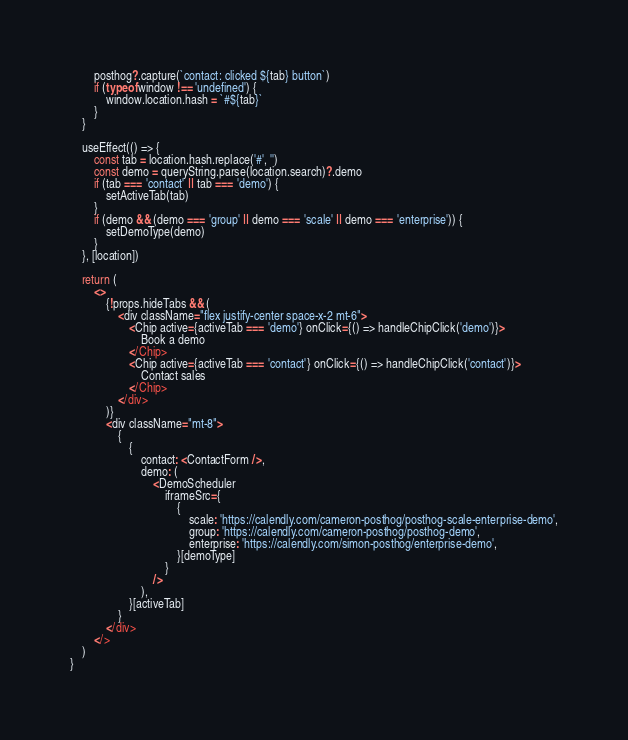<code> <loc_0><loc_0><loc_500><loc_500><_JavaScript_>        posthog?.capture(`contact: clicked ${tab} button`)
        if (typeof window !== 'undefined') {
            window.location.hash = `#${tab}`
        }
    }

    useEffect(() => {
        const tab = location.hash.replace('#', '')
        const demo = queryString.parse(location.search)?.demo
        if (tab === 'contact' || tab === 'demo') {
            setActiveTab(tab)
        }
        if (demo && (demo === 'group' || demo === 'scale' || demo === 'enterprise')) {
            setDemoType(demo)
        }
    }, [location])

    return (
        <>
            {!props.hideTabs && (
                <div className="flex justify-center space-x-2 mt-6">
                    <Chip active={activeTab === 'demo'} onClick={() => handleChipClick('demo')}>
                        Book a demo
                    </Chip>
                    <Chip active={activeTab === 'contact'} onClick={() => handleChipClick('contact')}>
                        Contact sales
                    </Chip>
                </div>
            )}
            <div className="mt-8">
                {
                    {
                        contact: <ContactForm />,
                        demo: (
                            <DemoScheduler
                                iframeSrc={
                                    {
                                        scale: 'https://calendly.com/cameron-posthog/posthog-scale-enterprise-demo',
                                        group: 'https://calendly.com/cameron-posthog/posthog-demo',
                                        enterprise: 'https://calendly.com/simon-posthog/enterprise-demo',
                                    }[demoType]
                                }
                            />
                        ),
                    }[activeTab]
                }
            </div>
        </>
    )
}
</code> 